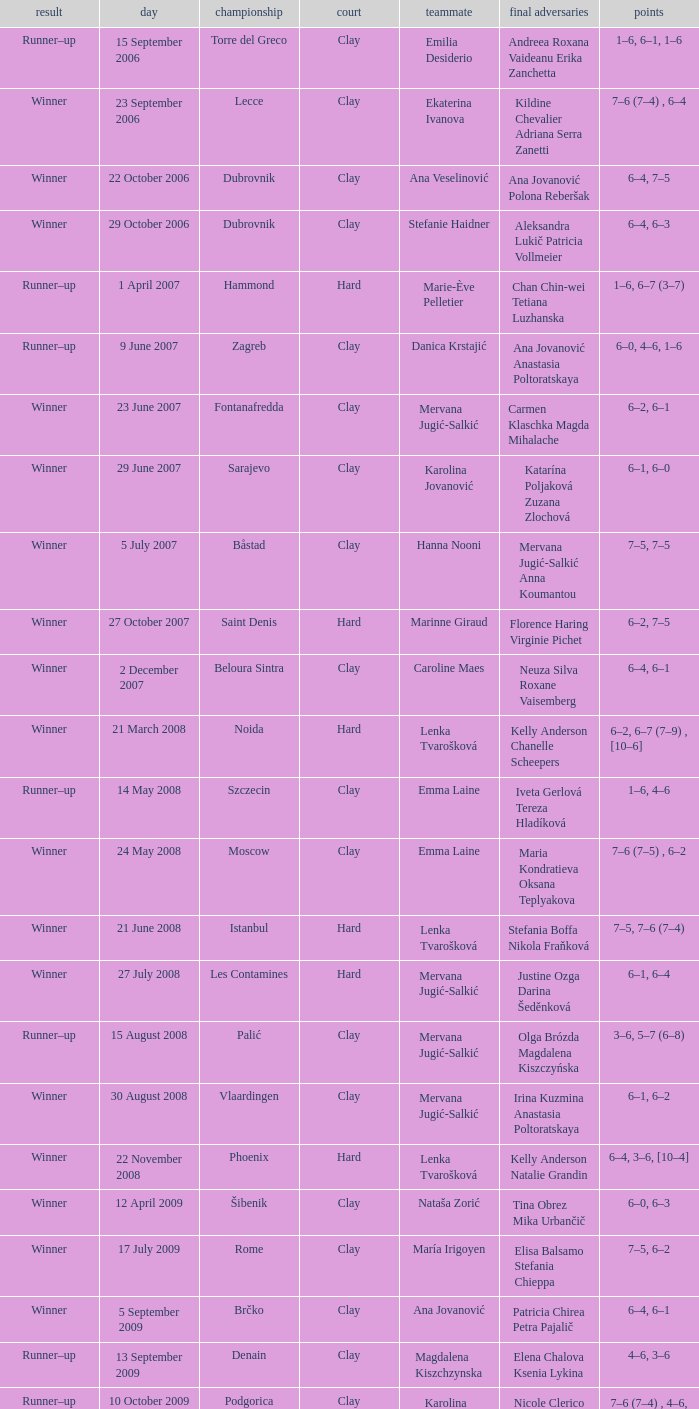Who were the opponents in the final at Noida? Kelly Anderson Chanelle Scheepers. 